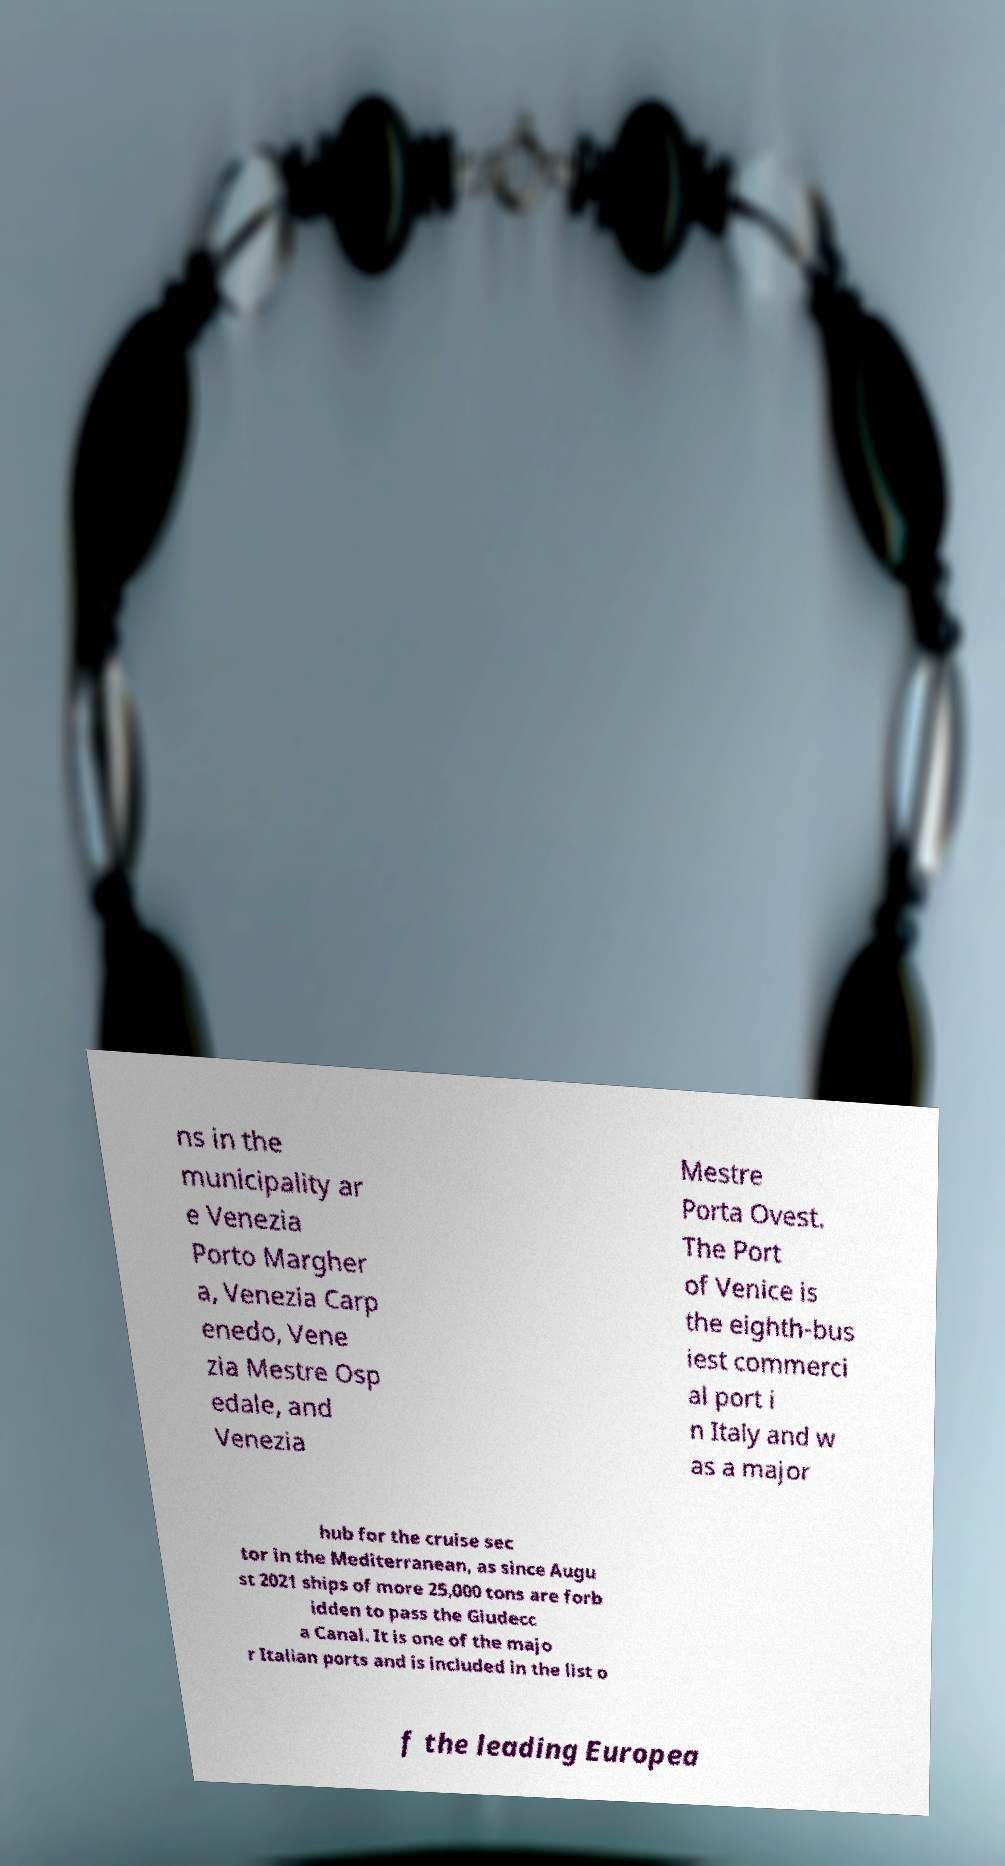Can you read and provide the text displayed in the image?This photo seems to have some interesting text. Can you extract and type it out for me? ns in the municipality ar e Venezia Porto Margher a, Venezia Carp enedo, Vene zia Mestre Osp edale, and Venezia Mestre Porta Ovest. The Port of Venice is the eighth-bus iest commerci al port i n Italy and w as a major hub for the cruise sec tor in the Mediterranean, as since Augu st 2021 ships of more 25,000 tons are forb idden to pass the Giudecc a Canal. It is one of the majo r Italian ports and is included in the list o f the leading Europea 